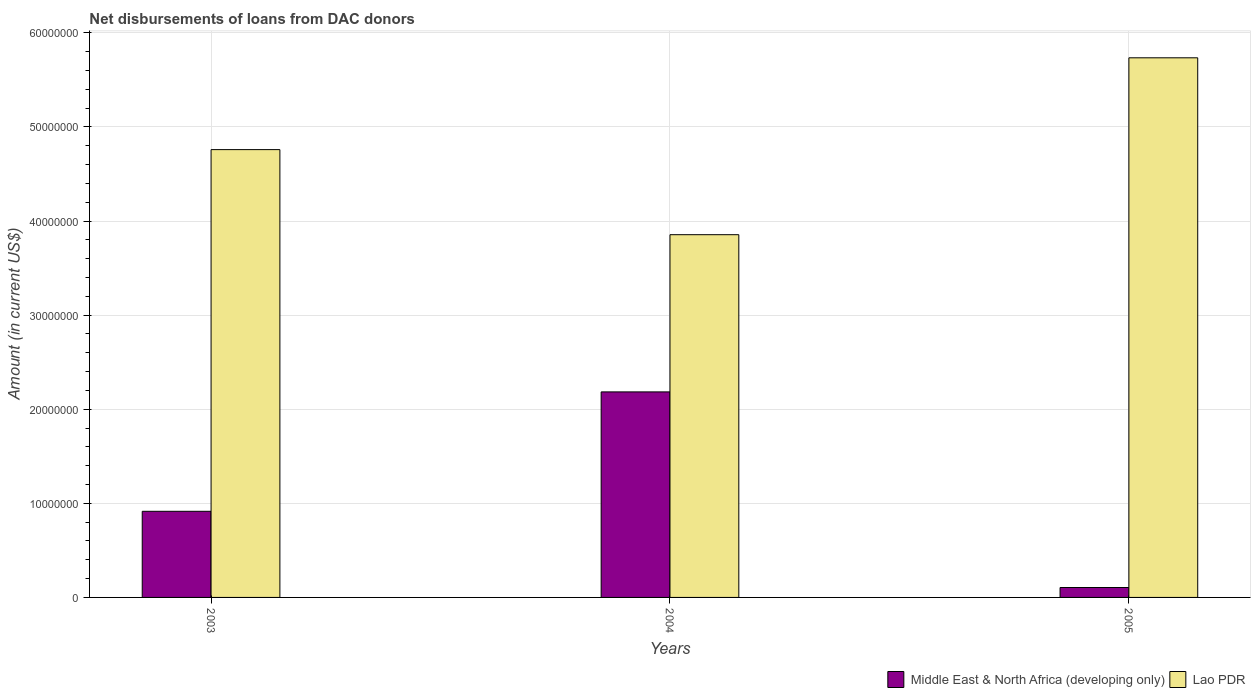How many groups of bars are there?
Your answer should be compact. 3. What is the label of the 3rd group of bars from the left?
Ensure brevity in your answer.  2005. In how many cases, is the number of bars for a given year not equal to the number of legend labels?
Offer a terse response. 0. What is the amount of loans disbursed in Lao PDR in 2003?
Give a very brief answer. 4.76e+07. Across all years, what is the maximum amount of loans disbursed in Middle East & North Africa (developing only)?
Make the answer very short. 2.18e+07. Across all years, what is the minimum amount of loans disbursed in Lao PDR?
Provide a short and direct response. 3.86e+07. In which year was the amount of loans disbursed in Lao PDR maximum?
Your response must be concise. 2005. In which year was the amount of loans disbursed in Lao PDR minimum?
Keep it short and to the point. 2004. What is the total amount of loans disbursed in Lao PDR in the graph?
Your answer should be very brief. 1.44e+08. What is the difference between the amount of loans disbursed in Middle East & North Africa (developing only) in 2003 and that in 2005?
Offer a terse response. 8.10e+06. What is the difference between the amount of loans disbursed in Middle East & North Africa (developing only) in 2003 and the amount of loans disbursed in Lao PDR in 2004?
Provide a short and direct response. -2.94e+07. What is the average amount of loans disbursed in Lao PDR per year?
Give a very brief answer. 4.78e+07. In the year 2004, what is the difference between the amount of loans disbursed in Middle East & North Africa (developing only) and amount of loans disbursed in Lao PDR?
Offer a terse response. -1.67e+07. In how many years, is the amount of loans disbursed in Lao PDR greater than 48000000 US$?
Give a very brief answer. 1. What is the ratio of the amount of loans disbursed in Middle East & North Africa (developing only) in 2003 to that in 2004?
Keep it short and to the point. 0.42. Is the amount of loans disbursed in Middle East & North Africa (developing only) in 2003 less than that in 2004?
Your answer should be compact. Yes. What is the difference between the highest and the second highest amount of loans disbursed in Lao PDR?
Provide a succinct answer. 9.76e+06. What is the difference between the highest and the lowest amount of loans disbursed in Middle East & North Africa (developing only)?
Provide a short and direct response. 2.08e+07. Is the sum of the amount of loans disbursed in Lao PDR in 2003 and 2005 greater than the maximum amount of loans disbursed in Middle East & North Africa (developing only) across all years?
Your answer should be compact. Yes. What does the 1st bar from the left in 2005 represents?
Make the answer very short. Middle East & North Africa (developing only). What does the 1st bar from the right in 2004 represents?
Make the answer very short. Lao PDR. How many bars are there?
Provide a succinct answer. 6. Are all the bars in the graph horizontal?
Provide a short and direct response. No. How many years are there in the graph?
Your answer should be very brief. 3. Are the values on the major ticks of Y-axis written in scientific E-notation?
Your response must be concise. No. Does the graph contain any zero values?
Ensure brevity in your answer.  No. What is the title of the graph?
Offer a terse response. Net disbursements of loans from DAC donors. What is the label or title of the X-axis?
Your response must be concise. Years. What is the label or title of the Y-axis?
Make the answer very short. Amount (in current US$). What is the Amount (in current US$) in Middle East & North Africa (developing only) in 2003?
Ensure brevity in your answer.  9.15e+06. What is the Amount (in current US$) of Lao PDR in 2003?
Make the answer very short. 4.76e+07. What is the Amount (in current US$) in Middle East & North Africa (developing only) in 2004?
Offer a very short reply. 2.18e+07. What is the Amount (in current US$) of Lao PDR in 2004?
Your answer should be very brief. 3.86e+07. What is the Amount (in current US$) of Middle East & North Africa (developing only) in 2005?
Your response must be concise. 1.05e+06. What is the Amount (in current US$) in Lao PDR in 2005?
Provide a short and direct response. 5.74e+07. Across all years, what is the maximum Amount (in current US$) in Middle East & North Africa (developing only)?
Make the answer very short. 2.18e+07. Across all years, what is the maximum Amount (in current US$) in Lao PDR?
Offer a very short reply. 5.74e+07. Across all years, what is the minimum Amount (in current US$) in Middle East & North Africa (developing only)?
Offer a terse response. 1.05e+06. Across all years, what is the minimum Amount (in current US$) of Lao PDR?
Offer a terse response. 3.86e+07. What is the total Amount (in current US$) in Middle East & North Africa (developing only) in the graph?
Make the answer very short. 3.21e+07. What is the total Amount (in current US$) of Lao PDR in the graph?
Your answer should be compact. 1.44e+08. What is the difference between the Amount (in current US$) in Middle East & North Africa (developing only) in 2003 and that in 2004?
Provide a succinct answer. -1.27e+07. What is the difference between the Amount (in current US$) in Lao PDR in 2003 and that in 2004?
Make the answer very short. 9.04e+06. What is the difference between the Amount (in current US$) of Middle East & North Africa (developing only) in 2003 and that in 2005?
Your response must be concise. 8.10e+06. What is the difference between the Amount (in current US$) of Lao PDR in 2003 and that in 2005?
Keep it short and to the point. -9.76e+06. What is the difference between the Amount (in current US$) in Middle East & North Africa (developing only) in 2004 and that in 2005?
Give a very brief answer. 2.08e+07. What is the difference between the Amount (in current US$) of Lao PDR in 2004 and that in 2005?
Make the answer very short. -1.88e+07. What is the difference between the Amount (in current US$) of Middle East & North Africa (developing only) in 2003 and the Amount (in current US$) of Lao PDR in 2004?
Keep it short and to the point. -2.94e+07. What is the difference between the Amount (in current US$) in Middle East & North Africa (developing only) in 2003 and the Amount (in current US$) in Lao PDR in 2005?
Offer a terse response. -4.82e+07. What is the difference between the Amount (in current US$) in Middle East & North Africa (developing only) in 2004 and the Amount (in current US$) in Lao PDR in 2005?
Give a very brief answer. -3.55e+07. What is the average Amount (in current US$) of Middle East & North Africa (developing only) per year?
Make the answer very short. 1.07e+07. What is the average Amount (in current US$) in Lao PDR per year?
Provide a short and direct response. 4.78e+07. In the year 2003, what is the difference between the Amount (in current US$) in Middle East & North Africa (developing only) and Amount (in current US$) in Lao PDR?
Offer a terse response. -3.84e+07. In the year 2004, what is the difference between the Amount (in current US$) in Middle East & North Africa (developing only) and Amount (in current US$) in Lao PDR?
Your response must be concise. -1.67e+07. In the year 2005, what is the difference between the Amount (in current US$) in Middle East & North Africa (developing only) and Amount (in current US$) in Lao PDR?
Your answer should be compact. -5.63e+07. What is the ratio of the Amount (in current US$) of Middle East & North Africa (developing only) in 2003 to that in 2004?
Keep it short and to the point. 0.42. What is the ratio of the Amount (in current US$) of Lao PDR in 2003 to that in 2004?
Your response must be concise. 1.23. What is the ratio of the Amount (in current US$) of Middle East & North Africa (developing only) in 2003 to that in 2005?
Ensure brevity in your answer.  8.68. What is the ratio of the Amount (in current US$) of Lao PDR in 2003 to that in 2005?
Make the answer very short. 0.83. What is the ratio of the Amount (in current US$) of Middle East & North Africa (developing only) in 2004 to that in 2005?
Your answer should be very brief. 20.73. What is the ratio of the Amount (in current US$) in Lao PDR in 2004 to that in 2005?
Your response must be concise. 0.67. What is the difference between the highest and the second highest Amount (in current US$) in Middle East & North Africa (developing only)?
Give a very brief answer. 1.27e+07. What is the difference between the highest and the second highest Amount (in current US$) of Lao PDR?
Provide a succinct answer. 9.76e+06. What is the difference between the highest and the lowest Amount (in current US$) in Middle East & North Africa (developing only)?
Your response must be concise. 2.08e+07. What is the difference between the highest and the lowest Amount (in current US$) of Lao PDR?
Provide a short and direct response. 1.88e+07. 